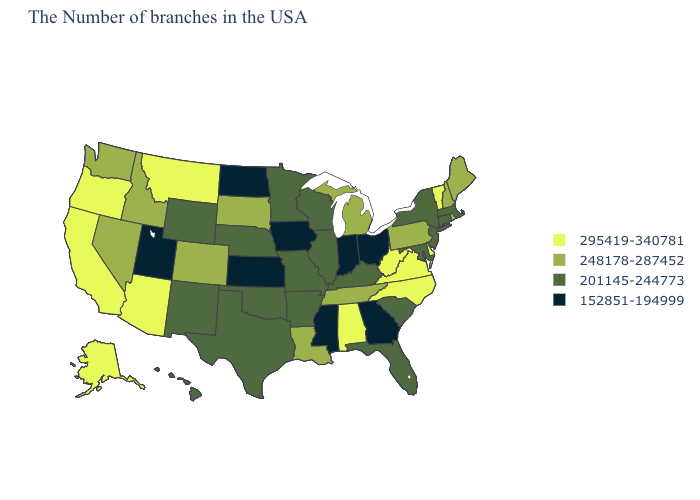Name the states that have a value in the range 295419-340781?
Keep it brief. Vermont, Delaware, Virginia, North Carolina, West Virginia, Alabama, Montana, Arizona, California, Oregon, Alaska. What is the value of Idaho?
Answer briefly. 248178-287452. Which states hav the highest value in the West?
Short answer required. Montana, Arizona, California, Oregon, Alaska. Name the states that have a value in the range 152851-194999?
Quick response, please. Ohio, Georgia, Indiana, Mississippi, Iowa, Kansas, North Dakota, Utah. Name the states that have a value in the range 295419-340781?
Answer briefly. Vermont, Delaware, Virginia, North Carolina, West Virginia, Alabama, Montana, Arizona, California, Oregon, Alaska. Name the states that have a value in the range 295419-340781?
Short answer required. Vermont, Delaware, Virginia, North Carolina, West Virginia, Alabama, Montana, Arizona, California, Oregon, Alaska. Does Kentucky have the same value as Minnesota?
Be succinct. Yes. What is the value of South Dakota?
Short answer required. 248178-287452. What is the value of New Jersey?
Keep it brief. 201145-244773. What is the lowest value in states that border Minnesota?
Quick response, please. 152851-194999. Is the legend a continuous bar?
Keep it brief. No. What is the value of Pennsylvania?
Keep it brief. 248178-287452. What is the lowest value in states that border Florida?
Write a very short answer. 152851-194999. Name the states that have a value in the range 152851-194999?
Short answer required. Ohio, Georgia, Indiana, Mississippi, Iowa, Kansas, North Dakota, Utah. Name the states that have a value in the range 248178-287452?
Quick response, please. Maine, Rhode Island, New Hampshire, Pennsylvania, Michigan, Tennessee, Louisiana, South Dakota, Colorado, Idaho, Nevada, Washington. 